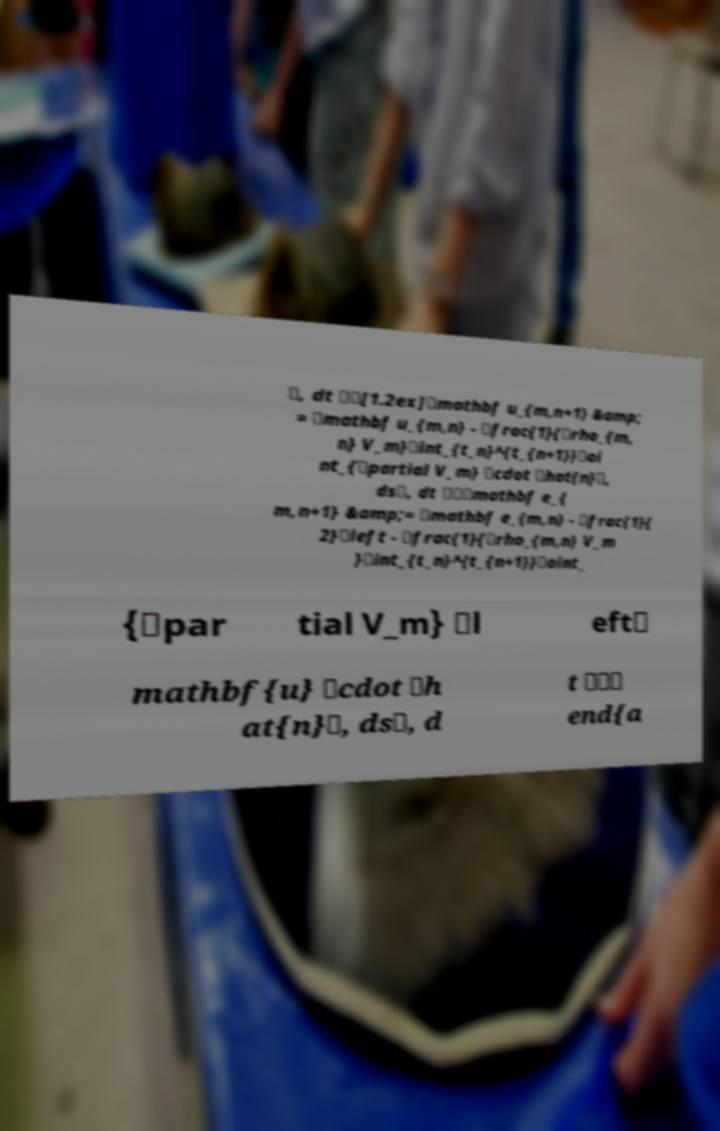For documentation purposes, I need the text within this image transcribed. Could you provide that? \, dt \\[1.2ex]\mathbf u_{m,n+1} &amp; = \mathbf u_{m,n} - \frac{1}{\rho_{m, n} V_m}\int_{t_n}^{t_{n+1}}\oi nt_{\partial V_m} \cdot \hat{n}\, ds\, dt \\\mathbf e_{ m,n+1} &amp;= \mathbf e_{m,n} - \frac{1}{ 2}\left - \frac{1}{\rho_{m,n} V_m }\int_{t_n}^{t_{n+1}}\oint_ {\par tial V_m} \l eft\ mathbf{u} \cdot \h at{n}\, ds\, d t \\\ end{a 